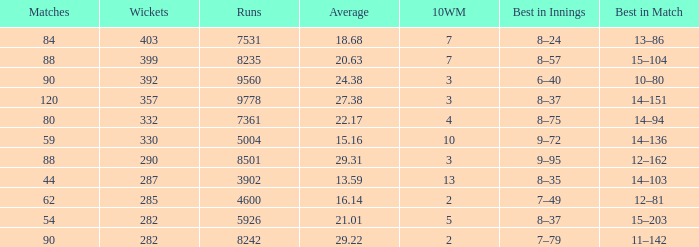How many wickets have been taken in under 44 matches and with less than 4600 runs scored? None. 